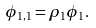<formula> <loc_0><loc_0><loc_500><loc_500>\phi _ { 1 , 1 } = \rho _ { 1 } \phi _ { 1 } .</formula> 